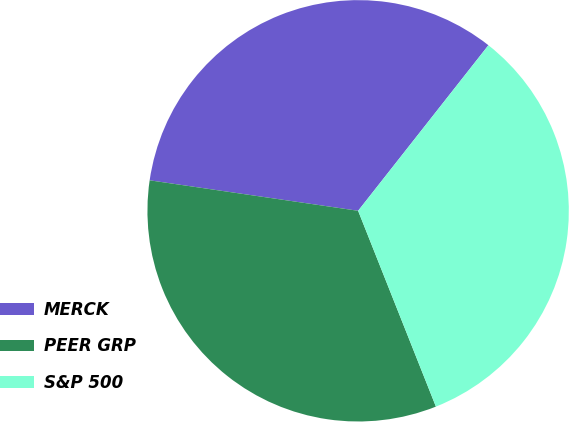<chart> <loc_0><loc_0><loc_500><loc_500><pie_chart><fcel>MERCK<fcel>PEER GRP<fcel>S&P 500<nl><fcel>33.3%<fcel>33.33%<fcel>33.37%<nl></chart> 